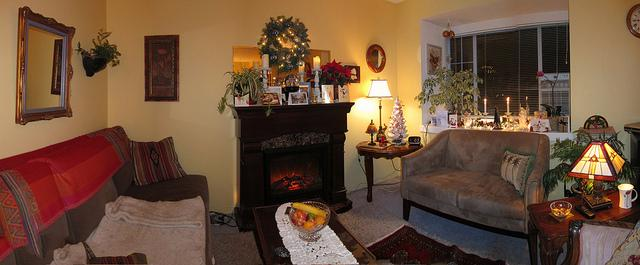What is the white object on the coffee table called? table cloth 